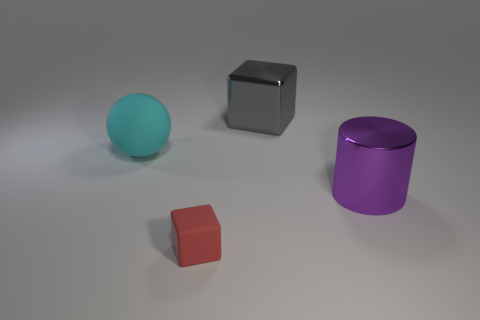Add 1 large purple cylinders. How many objects exist? 5 Subtract all balls. How many objects are left? 3 Subtract 1 blocks. How many blocks are left? 1 Subtract all blue balls. Subtract all yellow blocks. How many balls are left? 1 Subtract all gray shiny blocks. Subtract all big cylinders. How many objects are left? 2 Add 2 big purple cylinders. How many big purple cylinders are left? 3 Add 4 large spheres. How many large spheres exist? 5 Subtract all red cubes. How many cubes are left? 1 Subtract 0 yellow balls. How many objects are left? 4 